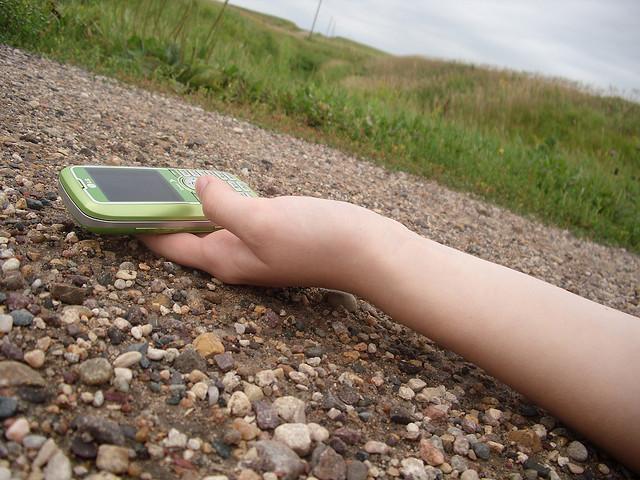How many elephants are there?
Give a very brief answer. 0. 